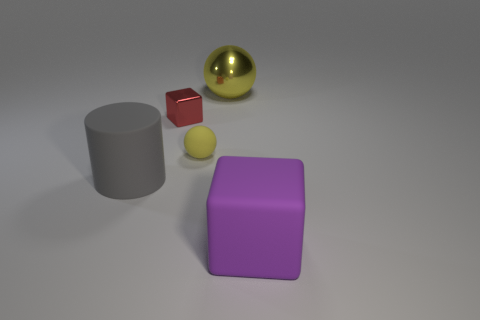There is a big rubber object that is in front of the gray rubber cylinder; is its color the same as the shiny cube?
Your answer should be compact. No. There is a block behind the large purple cube; is it the same size as the thing that is behind the tiny red shiny cube?
Give a very brief answer. No. What is the size of the sphere that is made of the same material as the purple thing?
Your answer should be very brief. Small. How many things are both in front of the metallic sphere and right of the metallic cube?
Your answer should be very brief. 2. What number of things are metallic things or big things left of the purple rubber block?
Make the answer very short. 3. There is a cube behind the large purple thing; what is its color?
Ensure brevity in your answer.  Red. What number of things are small cubes to the left of the big yellow metallic thing or big objects?
Offer a very short reply. 4. The block that is the same size as the cylinder is what color?
Provide a succinct answer. Purple. Are there more big yellow objects that are in front of the big cylinder than purple cubes?
Your answer should be very brief. No. What material is the large object that is both on the right side of the tiny yellow matte sphere and in front of the tiny metal block?
Offer a terse response. Rubber. 